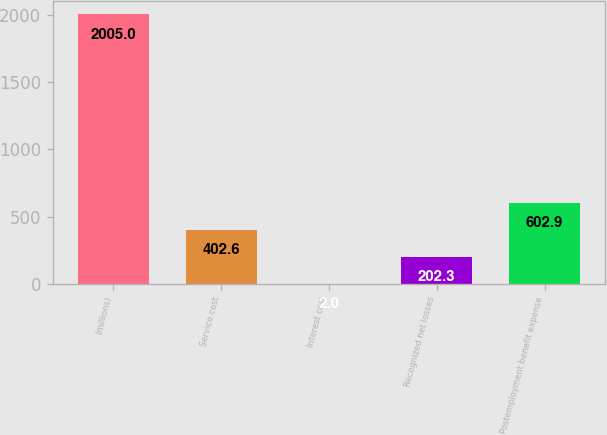Convert chart. <chart><loc_0><loc_0><loc_500><loc_500><bar_chart><fcel>(millions)<fcel>Service cost<fcel>Interest cost<fcel>Recognized net losses<fcel>Postemployment benefit expense<nl><fcel>2005<fcel>402.6<fcel>2<fcel>202.3<fcel>602.9<nl></chart> 